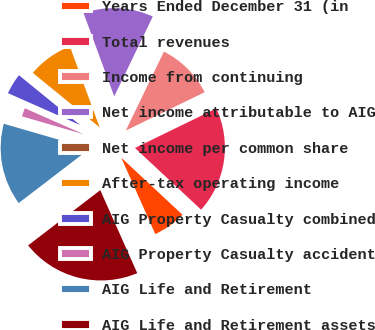<chart> <loc_0><loc_0><loc_500><loc_500><pie_chart><fcel>Years Ended December 31 (in<fcel>Total revenues<fcel>Income from continuing<fcel>Net income attributable to AIG<fcel>Net income per common share<fcel>After-tax operating income<fcel>AIG Property Casualty combined<fcel>AIG Property Casualty accident<fcel>AIG Life and Retirement<fcel>AIG Life and Retirement assets<nl><fcel>6.38%<fcel>19.15%<fcel>10.64%<fcel>12.77%<fcel>0.0%<fcel>8.51%<fcel>4.26%<fcel>2.13%<fcel>14.89%<fcel>21.28%<nl></chart> 